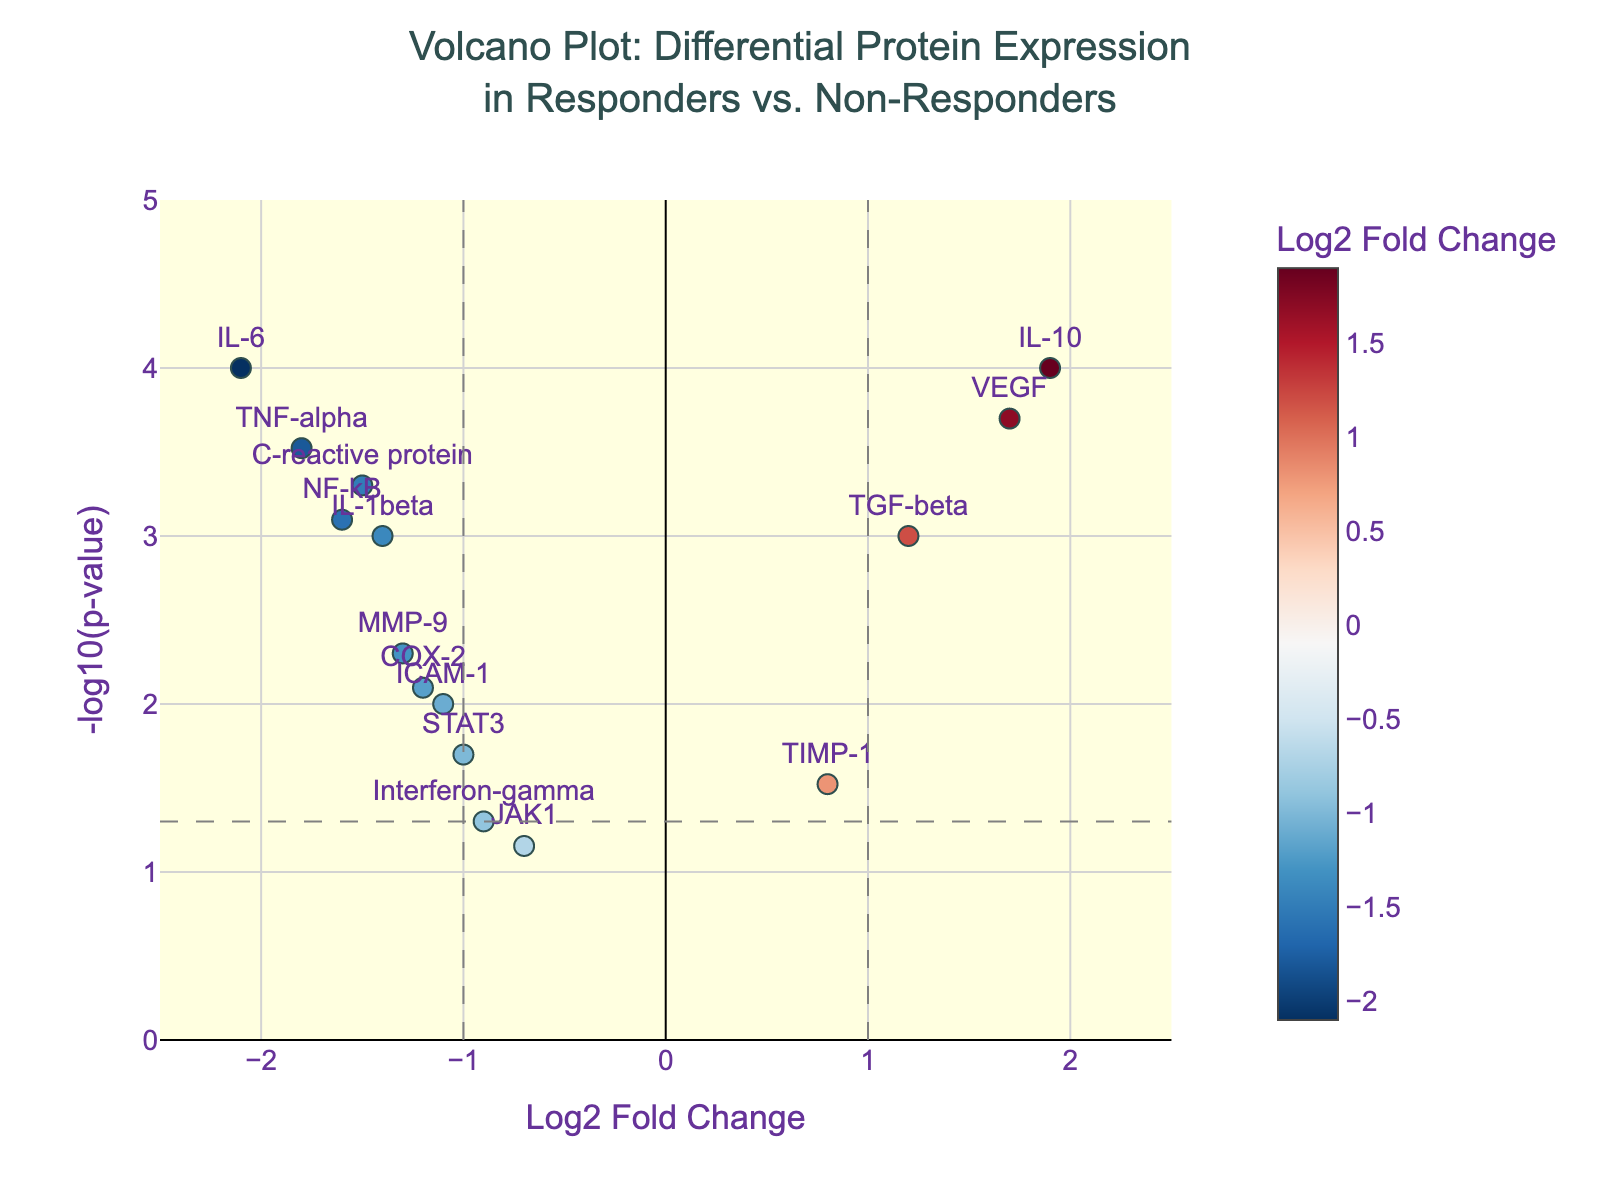How many proteins are displayed in the plot? To determine the number of proteins displayed, count the individual points in the plot. Each point represents one protein.
Answer: 15 What is the title of the plot? The plot's title is typically found at the top of the figure. Look for text that stands out, often larger and centrally positioned.
Answer: "Volcano Plot: Differential Protein Expression in Responders vs. Non-Responders" Which protein has the highest fold change among those with significant p-values? Significant p-values are those below 0.05 (horizontal dashed line). The protein with the highest Log2 Fold Change above this line can be identified by finding the highest positioned point on the right side that is well above this horizontal threshold.
Answer: IL-10 What is the threshold value for significance as marked in the plot? The horizontal dashed line marks the threshold for significance on the plot, which is at -log10(p-value) = -log10(0.05). Calculate -log10(0.05) to confirm this.
Answer: 1.3 Which proteins are downregulated significantly (i.e., Log2 Fold Change < -1 and p-value < 0.05)? Look for points that fall to the left of the vertical line at Log2 Fold Change = -1 and are also above the horizontal line at -log10(p-value) = 1.3.
Answer: IL-6, TNF-alpha, NF-kB How many proteins are significantly upregulated? Count the number of points that are to the right of the vertical line at Log2 Fold Change = 1 and are above the horizontal significance line at -log10(p-value) = 1.3.
Answer: 2 What is the Log2 Fold Change and p-value of Interferon-gamma? Find the point labeled "Interferon-gamma" and refer to its coordinates for Log2 Fold Change and the second axis for its p-value.
Answer: -0.9, 0.05 Compare the fold change values of VEGF and IL-1beta. Which one is higher? Find the points labeled "VEGF" and "IL-1beta" and compare their Log2 Fold Change values displayed next to them.
Answer: VEGF For the proteins that are significantly downregulated, which one has the lowest p-value? For significantly downregulated proteins (Log2 Fold Change < -1 and -log10(p-value) > 1.3), check the y-axis values to identify the point that is highest (lowest p-value).
Answer: IL-6 What is the color indication of the Log2 Fold Change and how is it applied in the scatter plot? The color bar indicates the range of Log2 Fold Change values. Points to the left (negative values) are colored towards blue, and those to the right (positive values) towards red. This gradient shows the range of protein expression changes.
Answer: RdBu_r 